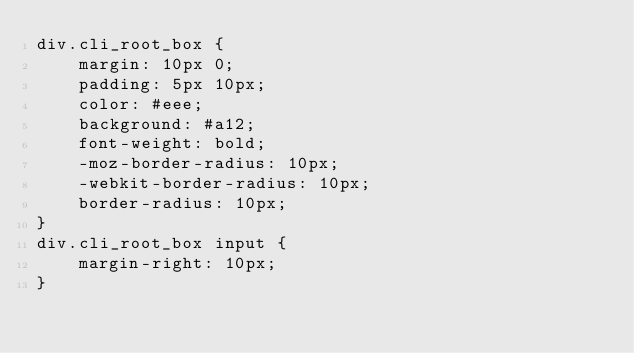<code> <loc_0><loc_0><loc_500><loc_500><_CSS_>div.cli_root_box {
	margin: 10px 0;
	padding: 5px 10px;
	color: #eee;
	background: #a12;
	font-weight: bold;
	-moz-border-radius: 10px;
	-webkit-border-radius: 10px;
	border-radius: 10px;
}
div.cli_root_box input {
	margin-right: 10px;
}
</code> 